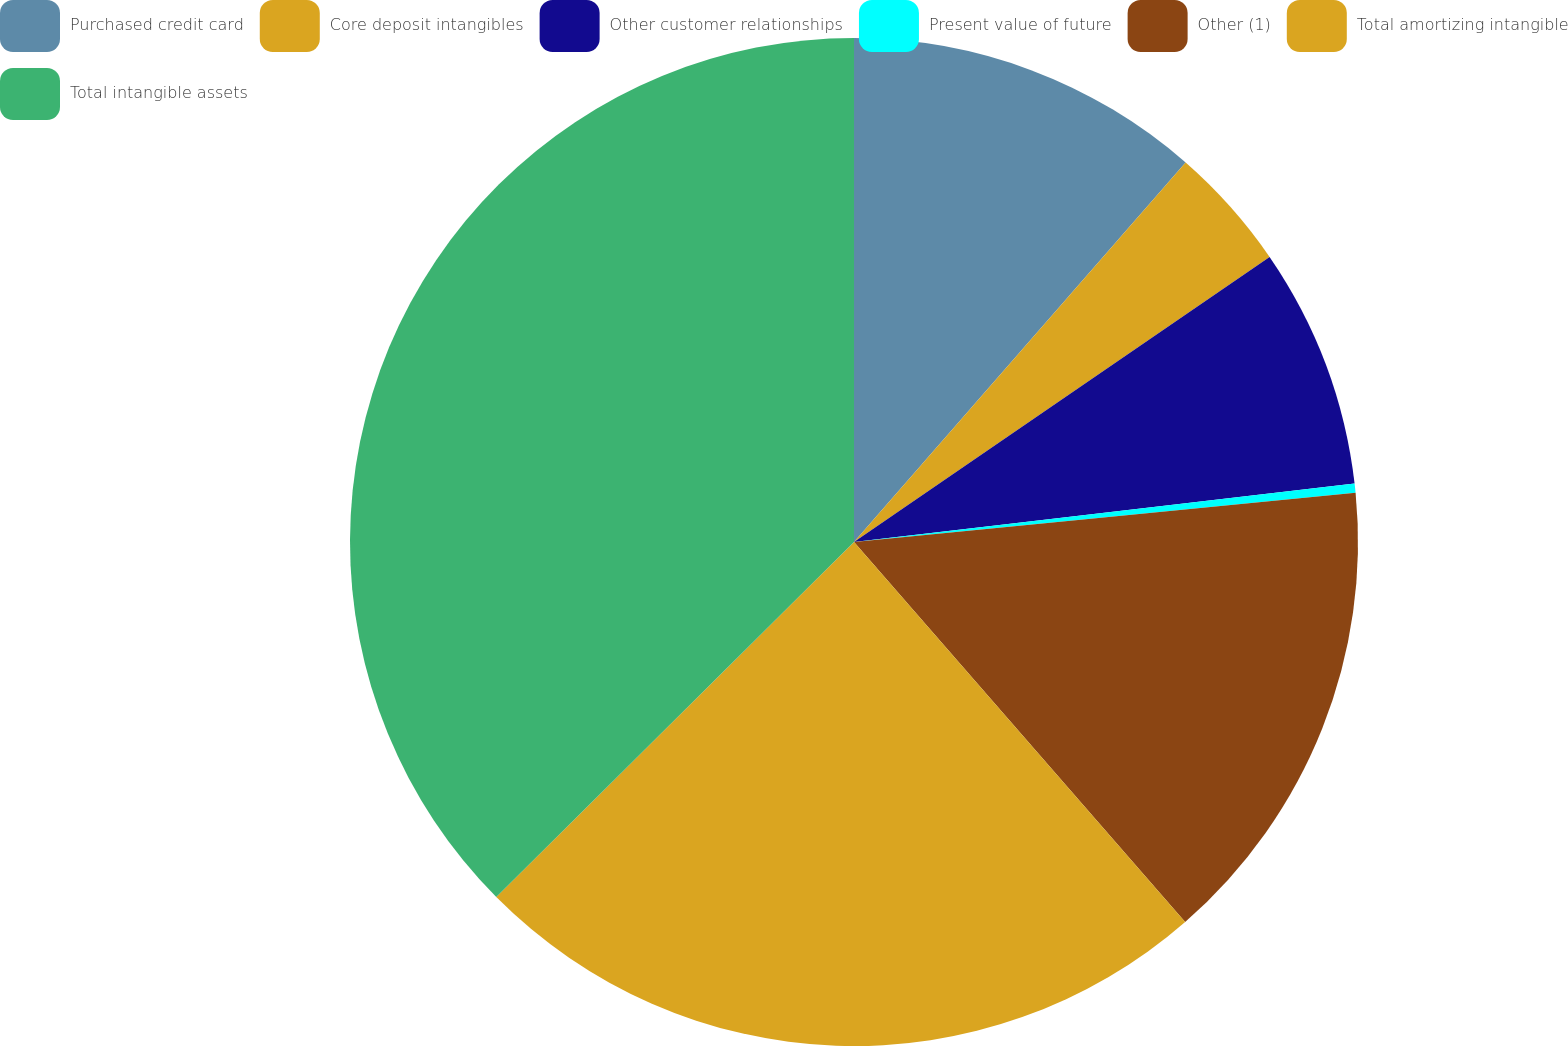<chart> <loc_0><loc_0><loc_500><loc_500><pie_chart><fcel>Purchased credit card<fcel>Core deposit intangibles<fcel>Other customer relationships<fcel>Present value of future<fcel>Other (1)<fcel>Total amortizing intangible<fcel>Total intangible assets<nl><fcel>11.43%<fcel>4.0%<fcel>7.72%<fcel>0.29%<fcel>15.15%<fcel>23.97%<fcel>37.44%<nl></chart> 